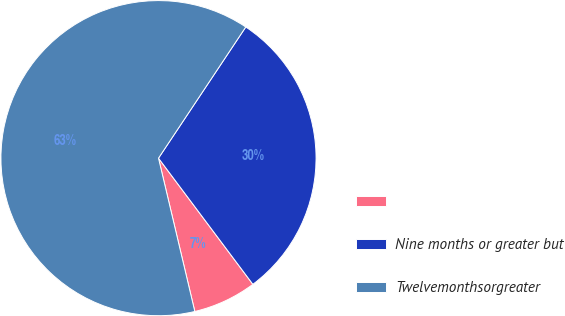<chart> <loc_0><loc_0><loc_500><loc_500><pie_chart><ecel><fcel>Nine months or greater but<fcel>Twelvemonthsorgreater<nl><fcel>6.52%<fcel>30.43%<fcel>63.04%<nl></chart> 